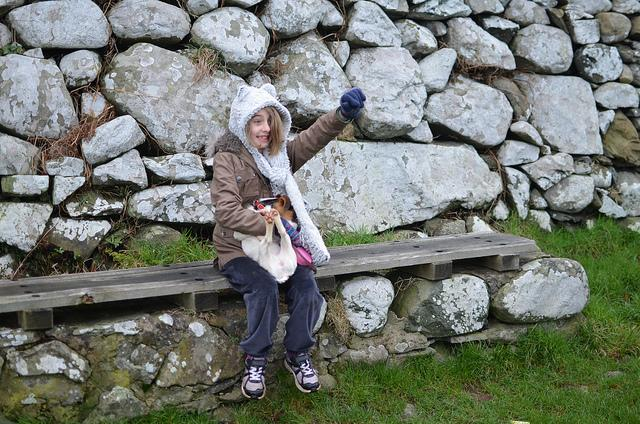What does the girl hold?

Choices:
A) rabbit
B) dog
C) teddy bear
D) rat dog 